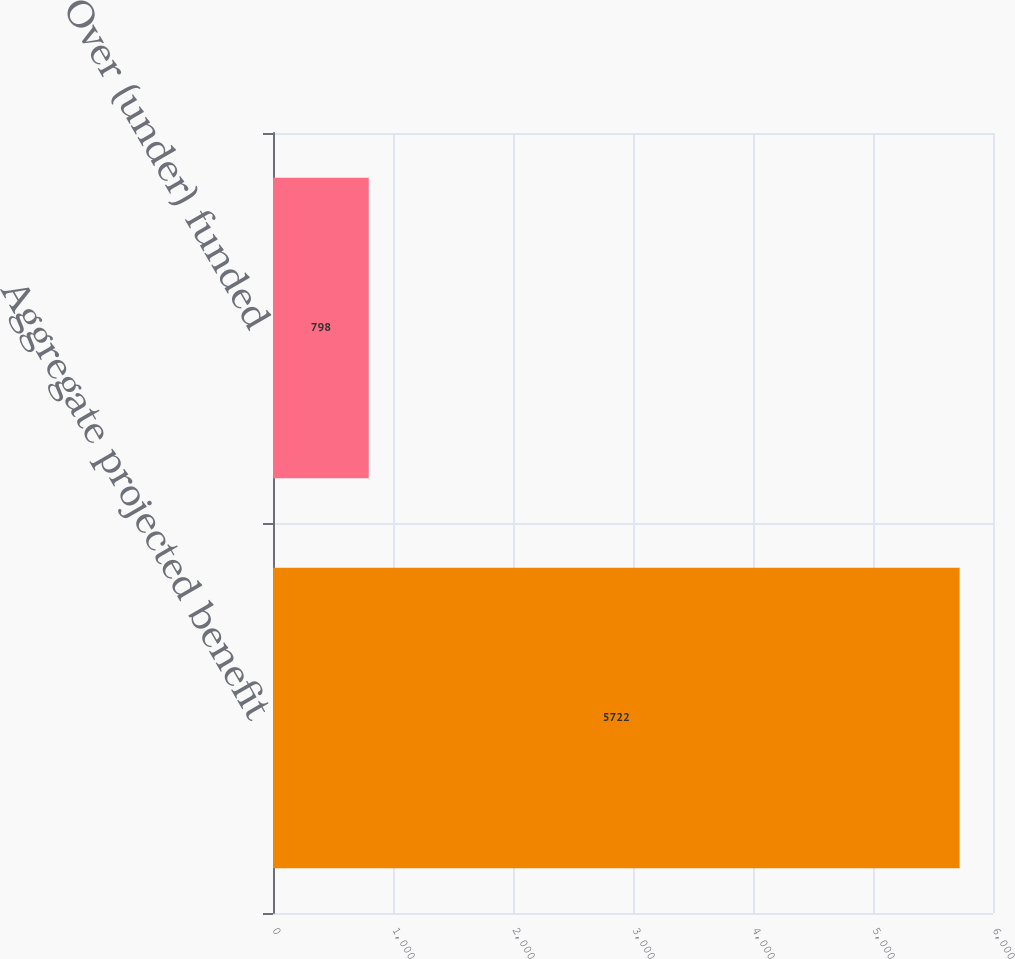<chart> <loc_0><loc_0><loc_500><loc_500><bar_chart><fcel>Aggregate projected benefit<fcel>Over (under) funded<nl><fcel>5722<fcel>798<nl></chart> 